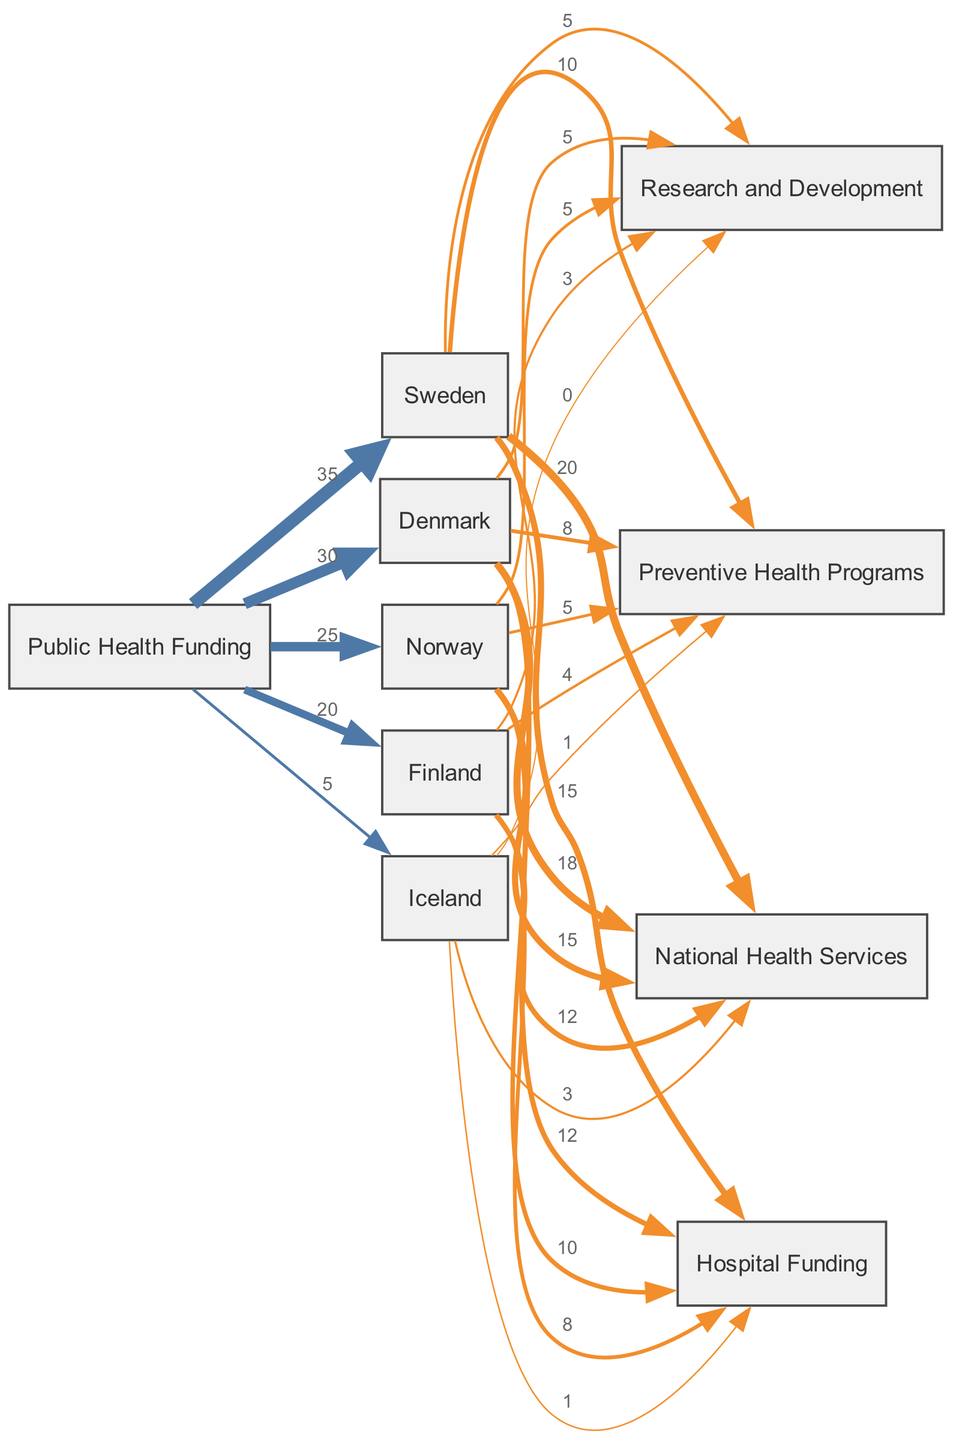What is the total public health funding for Norway? From the diagram, the value of public health funding that flows into Norway is 25.
Answer: 25 What percentage of Sweden's public health funding is allocated to National Health Services? Sweden has 20 allocated to National Health Services out of a total of 35 public health funding, which calculates to approximately 57.14% (20/35*100).
Answer: 57.14% Which country has the highest funding for Hospital Funding? The diagram shows that Sweden has the highest allocation of 15 for Hospital Funding compared to other countries.
Answer: Sweden What is the combined funding for Preventive Health Programs in Denmark and Finland? Denmark allocated 8 and Finland allocated 4 to Preventive Health Programs, which combine to a total of 12 (8 + 4).
Answer: 12 How many countries are represented in the diagram? The diagram features five countries: Sweden, Norway, Denmark, Finland, and Iceland.
Answer: 5 Which funding category received the least allocation from Iceland? The diagram indicates that Iceland allocated 0 to Research and Development, making it the least funded category from that country.
Answer: Research and Development What is the total public health funding for Denmark? The diagram indicates that Denmark received a total of 30 in public health funding.
Answer: 30 Which preventive health program received the least funding across all countries? Upon reviewing the diagram, it shows that Iceland provided only 1 towards Preventive Health Programs, which is the least among all contributions.
Answer: Iceland What is the total amount of funding from Sweden to Research and Development? The funding flow from Sweden to Research and Development is 5, reflecting the total allocation from this source.
Answer: 5 